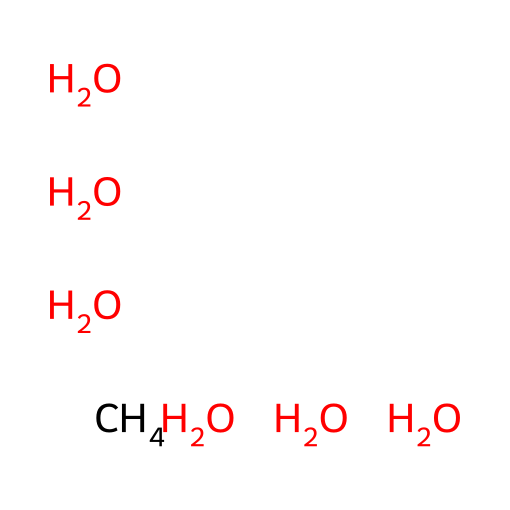what is the total number of atoms in this chemical? In the given SMILES representation, we can break down the components. The central carbon (C) is surrounded by multiple hydrogen (H) and oxygen (O) atoms. Counting each atom individually, there is 1 carbon atom, 8 hydrogen atoms, and 4 oxygen atoms, which sums to a total of 13 atoms.
Answer: 13 how many oxygen atoms are present in this chemical? From the SMILES, we can identify that there are 4 occurrences of the oxygen atom listed (O), meaning there are 4 oxygen atoms present in the structure.
Answer: 4 what type of chemical is represented by this SMILES? The chemical represented by the SMILES is comprised of multiple hydroxyl (-OH) groups attached to a central carbon, indicating that it is a type of alcohol, specifically a polyol.
Answer: alcohol how does the presence of multiple hydroxyl groups affect the solubility of this chemical? The presence of multiple hydroxyl groups significantly increases the solubility of the chemical in water. Each hydroxyl group can form hydrogen bonds with water molecules, enhancing polar interactions and allowing for better solubility in polar solvents.
Answer: increases what role do the hydrogen atoms play in this chemical? The hydrogen atoms are directly involved in the formation of hydroxyl groups, contributing to the overall structure's stability by allowing for hydrogen bonding. This bonding capability contributes to the chemical's polar nature and solubility.
Answer: stability how does the molecular arrangement relate to its behavior near deep-sea vents? The molecular arrangement with its multiple hydroxyl groups suggests a high degree of polarity, which can influence interactions with surrounding water and minerals near deep-sea vents, potentially facilitating the formation of methane hydrates in those environments.
Answer: influence formation what implications does this chemical's structure have on coral reef ecosystems? The structure indicates high reactivity and solubility, which can affect nutrient cycles and the overall biochemistry of marine environments, including interactions with coral reef ecosystems. These implications could relate to both nutrient availability and chemical interactions that impact coral health.
Answer: affect nutrient cycles 